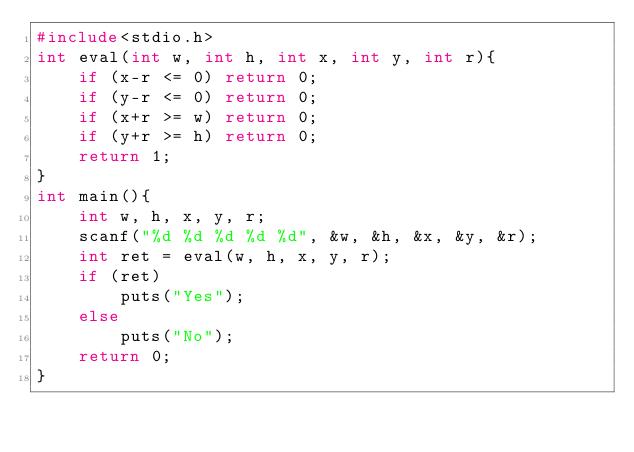<code> <loc_0><loc_0><loc_500><loc_500><_C_>#include<stdio.h>
int eval(int w, int h, int x, int y, int r){
    if (x-r <= 0) return 0;
    if (y-r <= 0) return 0;
    if (x+r >= w) return 0;
    if (y+r >= h) return 0;
    return 1;
}
int main(){
    int w, h, x, y, r;
    scanf("%d %d %d %d %d", &w, &h, &x, &y, &r);
    int ret = eval(w, h, x, y, r);
    if (ret)
        puts("Yes");
    else
        puts("No");
    return 0;
}</code> 